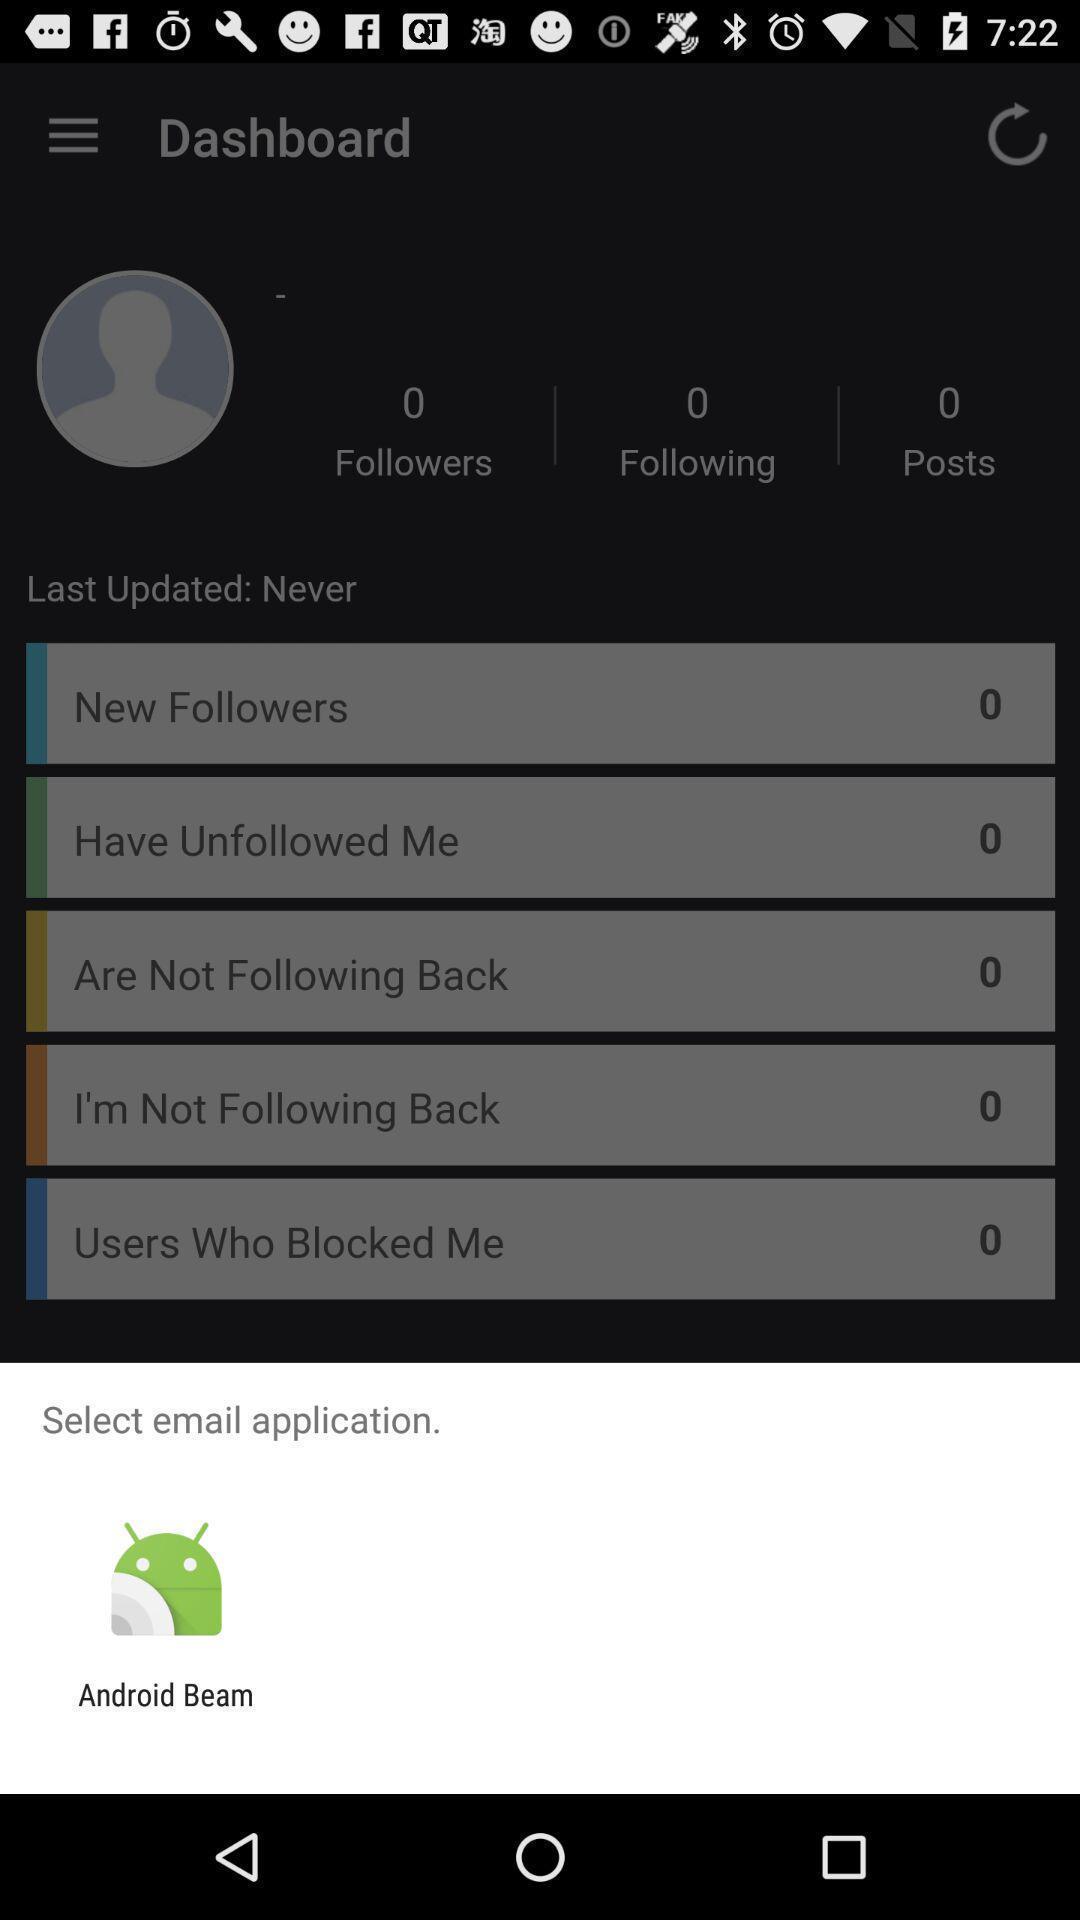Describe this image in words. Pop-up for selecting email application. 